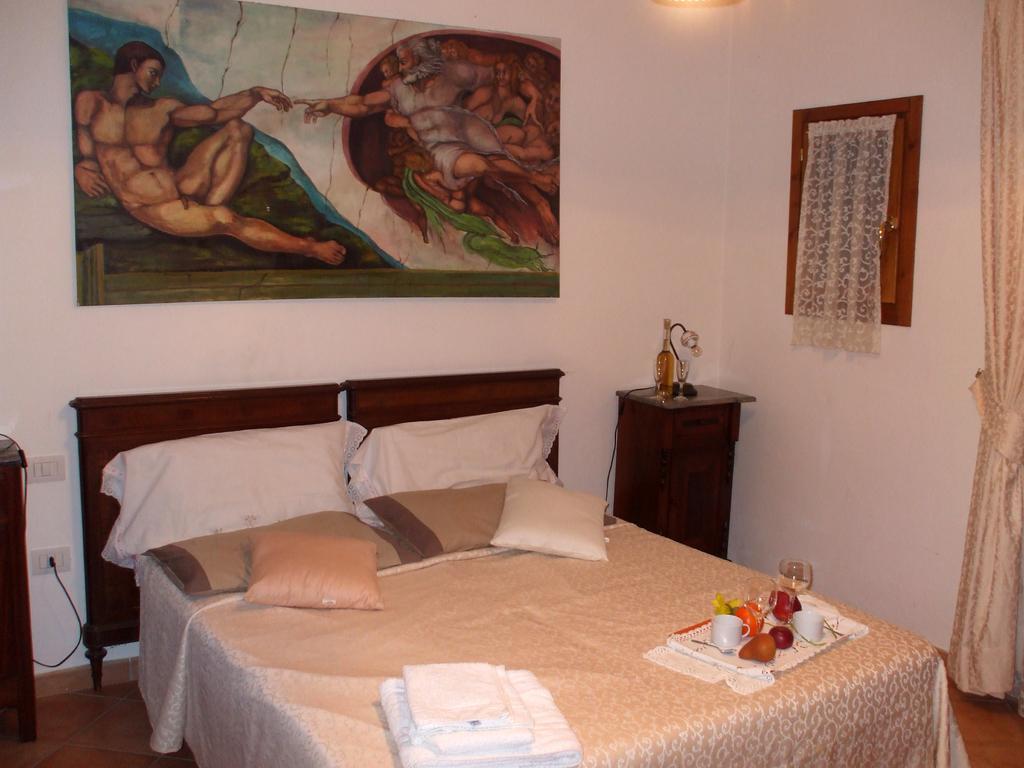Please provide a concise description of this image. In this picture we can see a few pillows and towels on the bed. There are cups, glasses and some fruits in a tray. There is a bottle, glass and a lamp on a wooden desk. We can see white curtains, switchboards and a painting on the wall. We can see a light. 